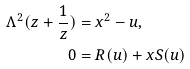Convert formula to latex. <formula><loc_0><loc_0><loc_500><loc_500>\Lambda ^ { 2 } ( z + \frac { 1 } { z } ) & = x ^ { 2 } - u , \\ 0 & = R ( u ) + x S ( u )</formula> 